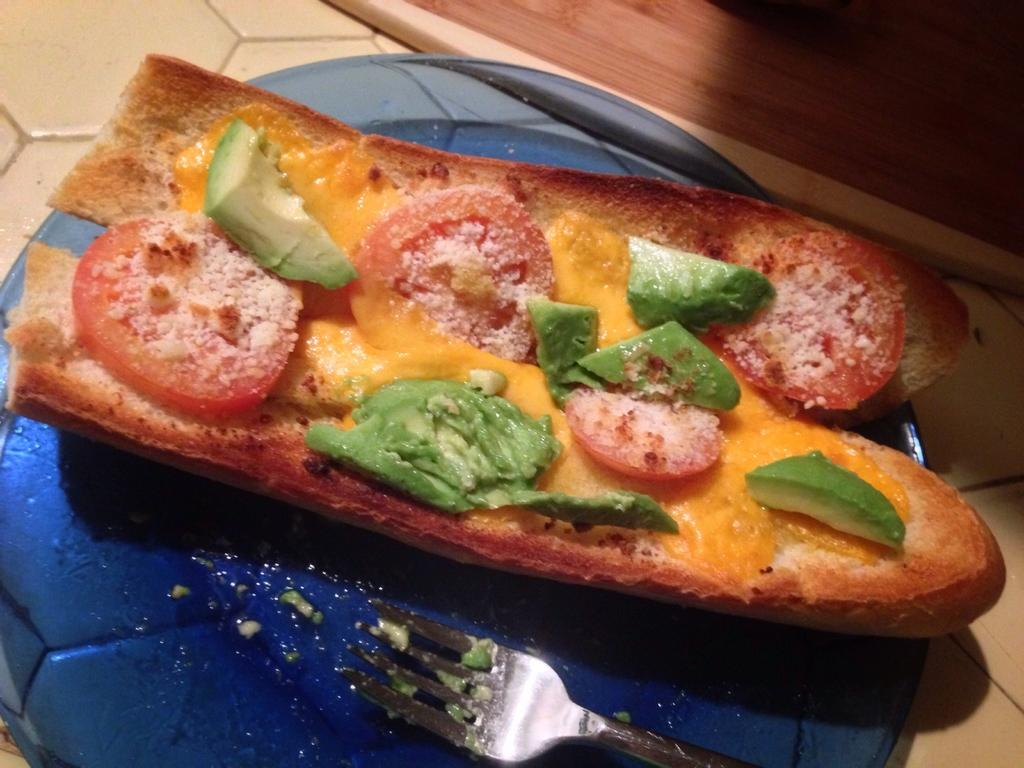What is: What is on the blue plate in the image? There is food on a blue plate in the image. Where is the blue plate located? The blue plate is placed on a surface. What type of object can be seen at the top of the image? There is a wooden object at the top of the image. What is the title of the book that the daughter is reading in the image? There is no book or daughter present in the image; it only features a blue plate with food, a surface, and a wooden object. 